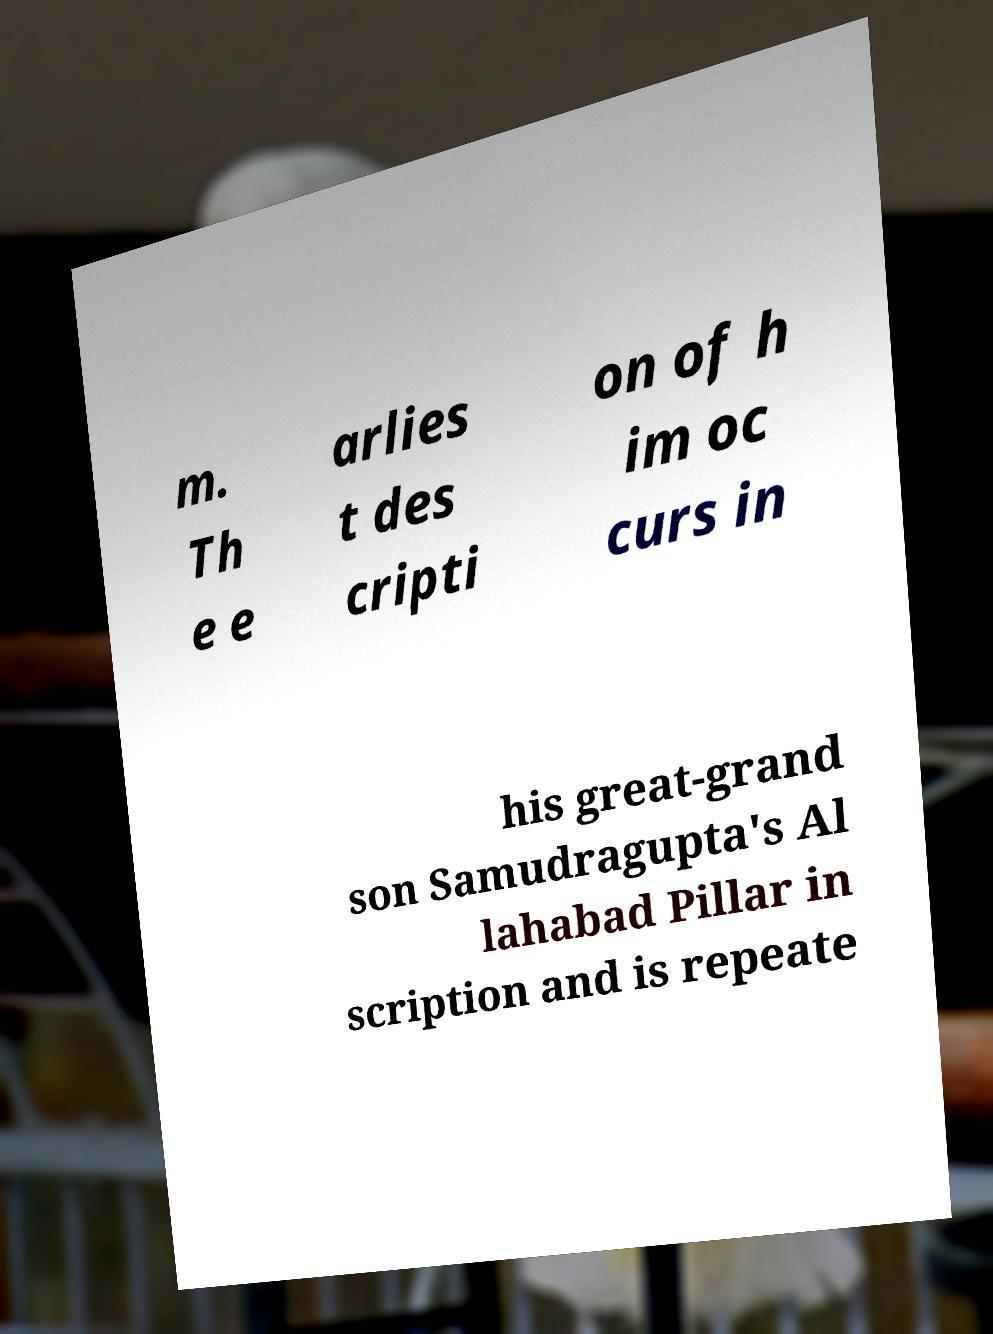Please read and relay the text visible in this image. What does it say? m. Th e e arlies t des cripti on of h im oc curs in his great-grand son Samudragupta's Al lahabad Pillar in scription and is repeate 